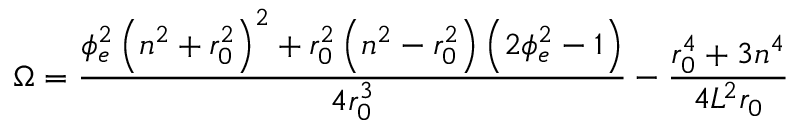Convert formula to latex. <formula><loc_0><loc_0><loc_500><loc_500>\Omega = \frac { \phi _ { e } ^ { 2 } \left ( n ^ { 2 } + r _ { 0 } ^ { 2 } \right ) ^ { 2 } + r _ { 0 } ^ { 2 } \left ( n ^ { 2 } - r _ { 0 } ^ { 2 } \right ) \left ( 2 \phi _ { e } ^ { 2 } - 1 \right ) } { 4 r _ { 0 } ^ { 3 } } - \frac { r _ { 0 } ^ { 4 } + 3 n ^ { 4 } } { 4 L ^ { 2 } r _ { 0 } }</formula> 